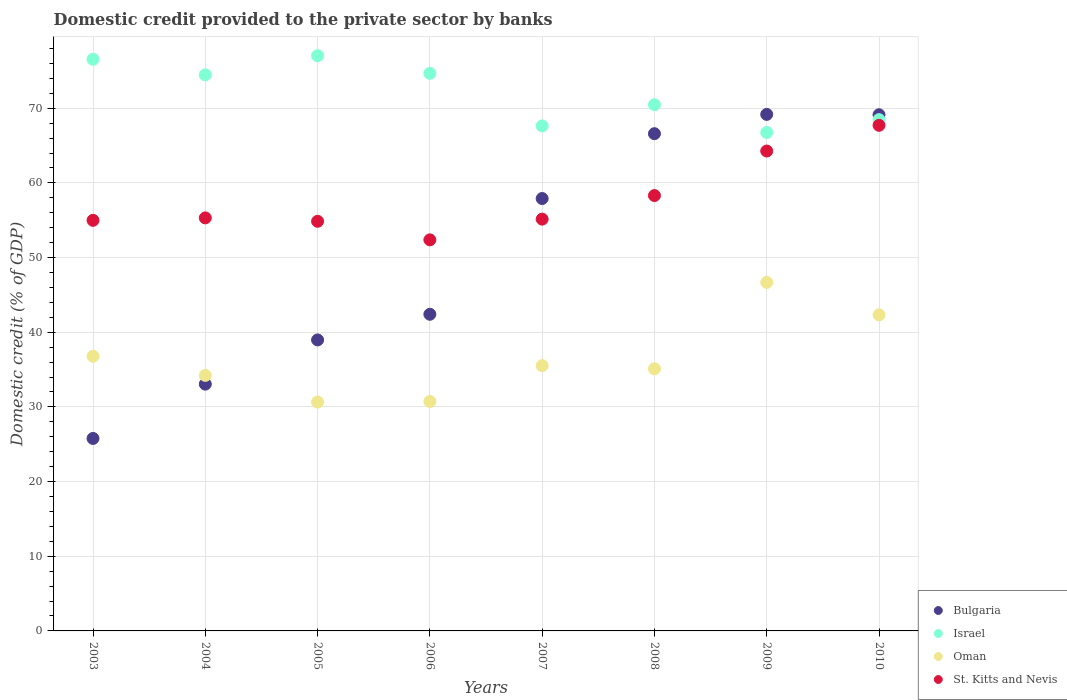How many different coloured dotlines are there?
Make the answer very short. 4. What is the domestic credit provided to the private sector by banks in Israel in 2010?
Keep it short and to the point. 68.48. Across all years, what is the maximum domestic credit provided to the private sector by banks in Bulgaria?
Provide a succinct answer. 69.18. Across all years, what is the minimum domestic credit provided to the private sector by banks in Oman?
Ensure brevity in your answer.  30.65. What is the total domestic credit provided to the private sector by banks in Bulgaria in the graph?
Your answer should be compact. 403.03. What is the difference between the domestic credit provided to the private sector by banks in Bulgaria in 2003 and that in 2007?
Give a very brief answer. -32.13. What is the difference between the domestic credit provided to the private sector by banks in Israel in 2005 and the domestic credit provided to the private sector by banks in Oman in 2007?
Your answer should be very brief. 41.51. What is the average domestic credit provided to the private sector by banks in St. Kitts and Nevis per year?
Your answer should be compact. 57.87. In the year 2010, what is the difference between the domestic credit provided to the private sector by banks in Oman and domestic credit provided to the private sector by banks in Bulgaria?
Ensure brevity in your answer.  -26.8. What is the ratio of the domestic credit provided to the private sector by banks in Israel in 2003 to that in 2005?
Ensure brevity in your answer.  0.99. Is the domestic credit provided to the private sector by banks in Bulgaria in 2003 less than that in 2005?
Provide a succinct answer. Yes. Is the difference between the domestic credit provided to the private sector by banks in Oman in 2004 and 2009 greater than the difference between the domestic credit provided to the private sector by banks in Bulgaria in 2004 and 2009?
Offer a very short reply. Yes. What is the difference between the highest and the second highest domestic credit provided to the private sector by banks in St. Kitts and Nevis?
Provide a short and direct response. 3.45. What is the difference between the highest and the lowest domestic credit provided to the private sector by banks in Oman?
Provide a succinct answer. 16.03. Is the sum of the domestic credit provided to the private sector by banks in Oman in 2008 and 2009 greater than the maximum domestic credit provided to the private sector by banks in St. Kitts and Nevis across all years?
Give a very brief answer. Yes. Does the domestic credit provided to the private sector by banks in Bulgaria monotonically increase over the years?
Give a very brief answer. No. Is the domestic credit provided to the private sector by banks in Israel strictly less than the domestic credit provided to the private sector by banks in St. Kitts and Nevis over the years?
Ensure brevity in your answer.  No. How many years are there in the graph?
Your answer should be very brief. 8. What is the difference between two consecutive major ticks on the Y-axis?
Provide a succinct answer. 10. Are the values on the major ticks of Y-axis written in scientific E-notation?
Give a very brief answer. No. Does the graph contain any zero values?
Offer a very short reply. No. How are the legend labels stacked?
Your answer should be compact. Vertical. What is the title of the graph?
Ensure brevity in your answer.  Domestic credit provided to the private sector by banks. What is the label or title of the X-axis?
Ensure brevity in your answer.  Years. What is the label or title of the Y-axis?
Offer a terse response. Domestic credit (% of GDP). What is the Domestic credit (% of GDP) in Bulgaria in 2003?
Keep it short and to the point. 25.78. What is the Domestic credit (% of GDP) in Israel in 2003?
Ensure brevity in your answer.  76.56. What is the Domestic credit (% of GDP) of Oman in 2003?
Your answer should be compact. 36.79. What is the Domestic credit (% of GDP) of St. Kitts and Nevis in 2003?
Your response must be concise. 54.99. What is the Domestic credit (% of GDP) in Bulgaria in 2004?
Your response must be concise. 33.05. What is the Domestic credit (% of GDP) in Israel in 2004?
Offer a very short reply. 74.47. What is the Domestic credit (% of GDP) in Oman in 2004?
Provide a succinct answer. 34.23. What is the Domestic credit (% of GDP) of St. Kitts and Nevis in 2004?
Provide a succinct answer. 55.32. What is the Domestic credit (% of GDP) in Bulgaria in 2005?
Your answer should be very brief. 38.97. What is the Domestic credit (% of GDP) in Israel in 2005?
Offer a very short reply. 77.04. What is the Domestic credit (% of GDP) in Oman in 2005?
Your answer should be very brief. 30.65. What is the Domestic credit (% of GDP) of St. Kitts and Nevis in 2005?
Keep it short and to the point. 54.86. What is the Domestic credit (% of GDP) of Bulgaria in 2006?
Ensure brevity in your answer.  42.41. What is the Domestic credit (% of GDP) of Israel in 2006?
Offer a very short reply. 74.67. What is the Domestic credit (% of GDP) in Oman in 2006?
Ensure brevity in your answer.  30.73. What is the Domestic credit (% of GDP) in St. Kitts and Nevis in 2006?
Provide a succinct answer. 52.38. What is the Domestic credit (% of GDP) in Bulgaria in 2007?
Your response must be concise. 57.91. What is the Domestic credit (% of GDP) in Israel in 2007?
Your answer should be compact. 67.64. What is the Domestic credit (% of GDP) of Oman in 2007?
Your response must be concise. 35.53. What is the Domestic credit (% of GDP) in St. Kitts and Nevis in 2007?
Offer a terse response. 55.15. What is the Domestic credit (% of GDP) of Bulgaria in 2008?
Your response must be concise. 66.59. What is the Domestic credit (% of GDP) of Israel in 2008?
Ensure brevity in your answer.  70.47. What is the Domestic credit (% of GDP) in Oman in 2008?
Your answer should be compact. 35.11. What is the Domestic credit (% of GDP) in St. Kitts and Nevis in 2008?
Make the answer very short. 58.31. What is the Domestic credit (% of GDP) in Bulgaria in 2009?
Offer a very short reply. 69.18. What is the Domestic credit (% of GDP) of Israel in 2009?
Provide a succinct answer. 66.76. What is the Domestic credit (% of GDP) of Oman in 2009?
Provide a short and direct response. 46.68. What is the Domestic credit (% of GDP) in St. Kitts and Nevis in 2009?
Your response must be concise. 64.27. What is the Domestic credit (% of GDP) of Bulgaria in 2010?
Keep it short and to the point. 69.13. What is the Domestic credit (% of GDP) of Israel in 2010?
Give a very brief answer. 68.48. What is the Domestic credit (% of GDP) of Oman in 2010?
Keep it short and to the point. 42.33. What is the Domestic credit (% of GDP) of St. Kitts and Nevis in 2010?
Your response must be concise. 67.72. Across all years, what is the maximum Domestic credit (% of GDP) in Bulgaria?
Offer a very short reply. 69.18. Across all years, what is the maximum Domestic credit (% of GDP) of Israel?
Your response must be concise. 77.04. Across all years, what is the maximum Domestic credit (% of GDP) in Oman?
Give a very brief answer. 46.68. Across all years, what is the maximum Domestic credit (% of GDP) in St. Kitts and Nevis?
Ensure brevity in your answer.  67.72. Across all years, what is the minimum Domestic credit (% of GDP) of Bulgaria?
Provide a succinct answer. 25.78. Across all years, what is the minimum Domestic credit (% of GDP) of Israel?
Your response must be concise. 66.76. Across all years, what is the minimum Domestic credit (% of GDP) of Oman?
Give a very brief answer. 30.65. Across all years, what is the minimum Domestic credit (% of GDP) in St. Kitts and Nevis?
Ensure brevity in your answer.  52.38. What is the total Domestic credit (% of GDP) of Bulgaria in the graph?
Offer a very short reply. 403.03. What is the total Domestic credit (% of GDP) of Israel in the graph?
Provide a short and direct response. 576.09. What is the total Domestic credit (% of GDP) of Oman in the graph?
Your response must be concise. 292.04. What is the total Domestic credit (% of GDP) in St. Kitts and Nevis in the graph?
Provide a succinct answer. 463. What is the difference between the Domestic credit (% of GDP) in Bulgaria in 2003 and that in 2004?
Provide a short and direct response. -7.27. What is the difference between the Domestic credit (% of GDP) of Israel in 2003 and that in 2004?
Ensure brevity in your answer.  2.08. What is the difference between the Domestic credit (% of GDP) in Oman in 2003 and that in 2004?
Ensure brevity in your answer.  2.56. What is the difference between the Domestic credit (% of GDP) in St. Kitts and Nevis in 2003 and that in 2004?
Your answer should be very brief. -0.33. What is the difference between the Domestic credit (% of GDP) of Bulgaria in 2003 and that in 2005?
Make the answer very short. -13.19. What is the difference between the Domestic credit (% of GDP) in Israel in 2003 and that in 2005?
Provide a succinct answer. -0.48. What is the difference between the Domestic credit (% of GDP) in Oman in 2003 and that in 2005?
Make the answer very short. 6.14. What is the difference between the Domestic credit (% of GDP) in St. Kitts and Nevis in 2003 and that in 2005?
Provide a succinct answer. 0.13. What is the difference between the Domestic credit (% of GDP) of Bulgaria in 2003 and that in 2006?
Give a very brief answer. -16.63. What is the difference between the Domestic credit (% of GDP) of Israel in 2003 and that in 2006?
Ensure brevity in your answer.  1.88. What is the difference between the Domestic credit (% of GDP) of Oman in 2003 and that in 2006?
Provide a succinct answer. 6.06. What is the difference between the Domestic credit (% of GDP) in St. Kitts and Nevis in 2003 and that in 2006?
Offer a very short reply. 2.62. What is the difference between the Domestic credit (% of GDP) in Bulgaria in 2003 and that in 2007?
Your answer should be very brief. -32.13. What is the difference between the Domestic credit (% of GDP) of Israel in 2003 and that in 2007?
Ensure brevity in your answer.  8.92. What is the difference between the Domestic credit (% of GDP) of Oman in 2003 and that in 2007?
Keep it short and to the point. 1.26. What is the difference between the Domestic credit (% of GDP) in St. Kitts and Nevis in 2003 and that in 2007?
Offer a very short reply. -0.16. What is the difference between the Domestic credit (% of GDP) of Bulgaria in 2003 and that in 2008?
Provide a short and direct response. -40.82. What is the difference between the Domestic credit (% of GDP) of Israel in 2003 and that in 2008?
Provide a succinct answer. 6.09. What is the difference between the Domestic credit (% of GDP) of Oman in 2003 and that in 2008?
Provide a succinct answer. 1.68. What is the difference between the Domestic credit (% of GDP) of St. Kitts and Nevis in 2003 and that in 2008?
Offer a terse response. -3.32. What is the difference between the Domestic credit (% of GDP) of Bulgaria in 2003 and that in 2009?
Your response must be concise. -43.4. What is the difference between the Domestic credit (% of GDP) in Israel in 2003 and that in 2009?
Make the answer very short. 9.8. What is the difference between the Domestic credit (% of GDP) of Oman in 2003 and that in 2009?
Give a very brief answer. -9.89. What is the difference between the Domestic credit (% of GDP) of St. Kitts and Nevis in 2003 and that in 2009?
Ensure brevity in your answer.  -9.28. What is the difference between the Domestic credit (% of GDP) of Bulgaria in 2003 and that in 2010?
Ensure brevity in your answer.  -43.35. What is the difference between the Domestic credit (% of GDP) in Israel in 2003 and that in 2010?
Provide a short and direct response. 8.08. What is the difference between the Domestic credit (% of GDP) in Oman in 2003 and that in 2010?
Offer a terse response. -5.55. What is the difference between the Domestic credit (% of GDP) of St. Kitts and Nevis in 2003 and that in 2010?
Your answer should be compact. -12.73. What is the difference between the Domestic credit (% of GDP) in Bulgaria in 2004 and that in 2005?
Give a very brief answer. -5.92. What is the difference between the Domestic credit (% of GDP) of Israel in 2004 and that in 2005?
Make the answer very short. -2.56. What is the difference between the Domestic credit (% of GDP) in Oman in 2004 and that in 2005?
Provide a succinct answer. 3.58. What is the difference between the Domestic credit (% of GDP) of St. Kitts and Nevis in 2004 and that in 2005?
Ensure brevity in your answer.  0.45. What is the difference between the Domestic credit (% of GDP) of Bulgaria in 2004 and that in 2006?
Give a very brief answer. -9.36. What is the difference between the Domestic credit (% of GDP) in Oman in 2004 and that in 2006?
Your response must be concise. 3.5. What is the difference between the Domestic credit (% of GDP) of St. Kitts and Nevis in 2004 and that in 2006?
Offer a very short reply. 2.94. What is the difference between the Domestic credit (% of GDP) of Bulgaria in 2004 and that in 2007?
Keep it short and to the point. -24.86. What is the difference between the Domestic credit (% of GDP) of Israel in 2004 and that in 2007?
Keep it short and to the point. 6.84. What is the difference between the Domestic credit (% of GDP) in Oman in 2004 and that in 2007?
Provide a short and direct response. -1.3. What is the difference between the Domestic credit (% of GDP) in St. Kitts and Nevis in 2004 and that in 2007?
Provide a succinct answer. 0.17. What is the difference between the Domestic credit (% of GDP) of Bulgaria in 2004 and that in 2008?
Keep it short and to the point. -33.54. What is the difference between the Domestic credit (% of GDP) in Israel in 2004 and that in 2008?
Offer a very short reply. 4.01. What is the difference between the Domestic credit (% of GDP) of Oman in 2004 and that in 2008?
Offer a terse response. -0.88. What is the difference between the Domestic credit (% of GDP) of St. Kitts and Nevis in 2004 and that in 2008?
Give a very brief answer. -2.99. What is the difference between the Domestic credit (% of GDP) in Bulgaria in 2004 and that in 2009?
Ensure brevity in your answer.  -36.13. What is the difference between the Domestic credit (% of GDP) in Israel in 2004 and that in 2009?
Give a very brief answer. 7.72. What is the difference between the Domestic credit (% of GDP) in Oman in 2004 and that in 2009?
Your answer should be very brief. -12.45. What is the difference between the Domestic credit (% of GDP) of St. Kitts and Nevis in 2004 and that in 2009?
Your answer should be very brief. -8.95. What is the difference between the Domestic credit (% of GDP) of Bulgaria in 2004 and that in 2010?
Your answer should be very brief. -36.08. What is the difference between the Domestic credit (% of GDP) of Israel in 2004 and that in 2010?
Ensure brevity in your answer.  6. What is the difference between the Domestic credit (% of GDP) of Oman in 2004 and that in 2010?
Provide a short and direct response. -8.11. What is the difference between the Domestic credit (% of GDP) in St. Kitts and Nevis in 2004 and that in 2010?
Make the answer very short. -12.4. What is the difference between the Domestic credit (% of GDP) in Bulgaria in 2005 and that in 2006?
Give a very brief answer. -3.44. What is the difference between the Domestic credit (% of GDP) in Israel in 2005 and that in 2006?
Offer a terse response. 2.36. What is the difference between the Domestic credit (% of GDP) in Oman in 2005 and that in 2006?
Make the answer very short. -0.08. What is the difference between the Domestic credit (% of GDP) in St. Kitts and Nevis in 2005 and that in 2006?
Provide a succinct answer. 2.49. What is the difference between the Domestic credit (% of GDP) of Bulgaria in 2005 and that in 2007?
Keep it short and to the point. -18.94. What is the difference between the Domestic credit (% of GDP) in Israel in 2005 and that in 2007?
Make the answer very short. 9.4. What is the difference between the Domestic credit (% of GDP) of Oman in 2005 and that in 2007?
Provide a short and direct response. -4.88. What is the difference between the Domestic credit (% of GDP) of St. Kitts and Nevis in 2005 and that in 2007?
Provide a succinct answer. -0.29. What is the difference between the Domestic credit (% of GDP) in Bulgaria in 2005 and that in 2008?
Offer a terse response. -27.62. What is the difference between the Domestic credit (% of GDP) in Israel in 2005 and that in 2008?
Give a very brief answer. 6.57. What is the difference between the Domestic credit (% of GDP) in Oman in 2005 and that in 2008?
Your answer should be compact. -4.46. What is the difference between the Domestic credit (% of GDP) in St. Kitts and Nevis in 2005 and that in 2008?
Keep it short and to the point. -3.44. What is the difference between the Domestic credit (% of GDP) of Bulgaria in 2005 and that in 2009?
Provide a succinct answer. -30.21. What is the difference between the Domestic credit (% of GDP) of Israel in 2005 and that in 2009?
Keep it short and to the point. 10.28. What is the difference between the Domestic credit (% of GDP) in Oman in 2005 and that in 2009?
Give a very brief answer. -16.03. What is the difference between the Domestic credit (% of GDP) of St. Kitts and Nevis in 2005 and that in 2009?
Make the answer very short. -9.41. What is the difference between the Domestic credit (% of GDP) in Bulgaria in 2005 and that in 2010?
Your response must be concise. -30.16. What is the difference between the Domestic credit (% of GDP) in Israel in 2005 and that in 2010?
Your answer should be compact. 8.56. What is the difference between the Domestic credit (% of GDP) in Oman in 2005 and that in 2010?
Provide a succinct answer. -11.68. What is the difference between the Domestic credit (% of GDP) of St. Kitts and Nevis in 2005 and that in 2010?
Offer a terse response. -12.85. What is the difference between the Domestic credit (% of GDP) of Bulgaria in 2006 and that in 2007?
Ensure brevity in your answer.  -15.5. What is the difference between the Domestic credit (% of GDP) in Israel in 2006 and that in 2007?
Make the answer very short. 7.04. What is the difference between the Domestic credit (% of GDP) of Oman in 2006 and that in 2007?
Your answer should be compact. -4.8. What is the difference between the Domestic credit (% of GDP) in St. Kitts and Nevis in 2006 and that in 2007?
Give a very brief answer. -2.77. What is the difference between the Domestic credit (% of GDP) of Bulgaria in 2006 and that in 2008?
Ensure brevity in your answer.  -24.19. What is the difference between the Domestic credit (% of GDP) in Israel in 2006 and that in 2008?
Give a very brief answer. 4.21. What is the difference between the Domestic credit (% of GDP) in Oman in 2006 and that in 2008?
Give a very brief answer. -4.38. What is the difference between the Domestic credit (% of GDP) in St. Kitts and Nevis in 2006 and that in 2008?
Your response must be concise. -5.93. What is the difference between the Domestic credit (% of GDP) in Bulgaria in 2006 and that in 2009?
Give a very brief answer. -26.77. What is the difference between the Domestic credit (% of GDP) of Israel in 2006 and that in 2009?
Provide a short and direct response. 7.92. What is the difference between the Domestic credit (% of GDP) of Oman in 2006 and that in 2009?
Make the answer very short. -15.95. What is the difference between the Domestic credit (% of GDP) of St. Kitts and Nevis in 2006 and that in 2009?
Your response must be concise. -11.9. What is the difference between the Domestic credit (% of GDP) of Bulgaria in 2006 and that in 2010?
Your response must be concise. -26.72. What is the difference between the Domestic credit (% of GDP) in Israel in 2006 and that in 2010?
Keep it short and to the point. 6.2. What is the difference between the Domestic credit (% of GDP) of Oman in 2006 and that in 2010?
Offer a very short reply. -11.6. What is the difference between the Domestic credit (% of GDP) in St. Kitts and Nevis in 2006 and that in 2010?
Provide a succinct answer. -15.34. What is the difference between the Domestic credit (% of GDP) in Bulgaria in 2007 and that in 2008?
Offer a terse response. -8.68. What is the difference between the Domestic credit (% of GDP) of Israel in 2007 and that in 2008?
Offer a terse response. -2.83. What is the difference between the Domestic credit (% of GDP) of Oman in 2007 and that in 2008?
Make the answer very short. 0.42. What is the difference between the Domestic credit (% of GDP) of St. Kitts and Nevis in 2007 and that in 2008?
Make the answer very short. -3.16. What is the difference between the Domestic credit (% of GDP) of Bulgaria in 2007 and that in 2009?
Offer a very short reply. -11.27. What is the difference between the Domestic credit (% of GDP) of Israel in 2007 and that in 2009?
Ensure brevity in your answer.  0.88. What is the difference between the Domestic credit (% of GDP) of Oman in 2007 and that in 2009?
Offer a very short reply. -11.15. What is the difference between the Domestic credit (% of GDP) of St. Kitts and Nevis in 2007 and that in 2009?
Give a very brief answer. -9.12. What is the difference between the Domestic credit (% of GDP) of Bulgaria in 2007 and that in 2010?
Your answer should be very brief. -11.22. What is the difference between the Domestic credit (% of GDP) in Israel in 2007 and that in 2010?
Offer a terse response. -0.84. What is the difference between the Domestic credit (% of GDP) in Oman in 2007 and that in 2010?
Keep it short and to the point. -6.81. What is the difference between the Domestic credit (% of GDP) in St. Kitts and Nevis in 2007 and that in 2010?
Make the answer very short. -12.57. What is the difference between the Domestic credit (% of GDP) in Bulgaria in 2008 and that in 2009?
Make the answer very short. -2.58. What is the difference between the Domestic credit (% of GDP) in Israel in 2008 and that in 2009?
Your answer should be very brief. 3.71. What is the difference between the Domestic credit (% of GDP) of Oman in 2008 and that in 2009?
Give a very brief answer. -11.57. What is the difference between the Domestic credit (% of GDP) of St. Kitts and Nevis in 2008 and that in 2009?
Your response must be concise. -5.96. What is the difference between the Domestic credit (% of GDP) in Bulgaria in 2008 and that in 2010?
Give a very brief answer. -2.54. What is the difference between the Domestic credit (% of GDP) of Israel in 2008 and that in 2010?
Your answer should be very brief. 1.99. What is the difference between the Domestic credit (% of GDP) in Oman in 2008 and that in 2010?
Make the answer very short. -7.23. What is the difference between the Domestic credit (% of GDP) in St. Kitts and Nevis in 2008 and that in 2010?
Your response must be concise. -9.41. What is the difference between the Domestic credit (% of GDP) of Bulgaria in 2009 and that in 2010?
Make the answer very short. 0.05. What is the difference between the Domestic credit (% of GDP) of Israel in 2009 and that in 2010?
Your response must be concise. -1.72. What is the difference between the Domestic credit (% of GDP) of Oman in 2009 and that in 2010?
Provide a short and direct response. 4.34. What is the difference between the Domestic credit (% of GDP) in St. Kitts and Nevis in 2009 and that in 2010?
Give a very brief answer. -3.45. What is the difference between the Domestic credit (% of GDP) in Bulgaria in 2003 and the Domestic credit (% of GDP) in Israel in 2004?
Keep it short and to the point. -48.7. What is the difference between the Domestic credit (% of GDP) of Bulgaria in 2003 and the Domestic credit (% of GDP) of Oman in 2004?
Make the answer very short. -8.45. What is the difference between the Domestic credit (% of GDP) in Bulgaria in 2003 and the Domestic credit (% of GDP) in St. Kitts and Nevis in 2004?
Provide a succinct answer. -29.54. What is the difference between the Domestic credit (% of GDP) in Israel in 2003 and the Domestic credit (% of GDP) in Oman in 2004?
Ensure brevity in your answer.  42.33. What is the difference between the Domestic credit (% of GDP) of Israel in 2003 and the Domestic credit (% of GDP) of St. Kitts and Nevis in 2004?
Your answer should be very brief. 21.24. What is the difference between the Domestic credit (% of GDP) in Oman in 2003 and the Domestic credit (% of GDP) in St. Kitts and Nevis in 2004?
Your answer should be compact. -18.53. What is the difference between the Domestic credit (% of GDP) in Bulgaria in 2003 and the Domestic credit (% of GDP) in Israel in 2005?
Keep it short and to the point. -51.26. What is the difference between the Domestic credit (% of GDP) of Bulgaria in 2003 and the Domestic credit (% of GDP) of Oman in 2005?
Make the answer very short. -4.87. What is the difference between the Domestic credit (% of GDP) in Bulgaria in 2003 and the Domestic credit (% of GDP) in St. Kitts and Nevis in 2005?
Your answer should be very brief. -29.09. What is the difference between the Domestic credit (% of GDP) in Israel in 2003 and the Domestic credit (% of GDP) in Oman in 2005?
Your answer should be very brief. 45.91. What is the difference between the Domestic credit (% of GDP) in Israel in 2003 and the Domestic credit (% of GDP) in St. Kitts and Nevis in 2005?
Make the answer very short. 21.7. What is the difference between the Domestic credit (% of GDP) of Oman in 2003 and the Domestic credit (% of GDP) of St. Kitts and Nevis in 2005?
Make the answer very short. -18.08. What is the difference between the Domestic credit (% of GDP) in Bulgaria in 2003 and the Domestic credit (% of GDP) in Israel in 2006?
Offer a terse response. -48.9. What is the difference between the Domestic credit (% of GDP) in Bulgaria in 2003 and the Domestic credit (% of GDP) in Oman in 2006?
Your answer should be compact. -4.95. What is the difference between the Domestic credit (% of GDP) in Bulgaria in 2003 and the Domestic credit (% of GDP) in St. Kitts and Nevis in 2006?
Offer a terse response. -26.6. What is the difference between the Domestic credit (% of GDP) of Israel in 2003 and the Domestic credit (% of GDP) of Oman in 2006?
Ensure brevity in your answer.  45.83. What is the difference between the Domestic credit (% of GDP) in Israel in 2003 and the Domestic credit (% of GDP) in St. Kitts and Nevis in 2006?
Offer a terse response. 24.18. What is the difference between the Domestic credit (% of GDP) in Oman in 2003 and the Domestic credit (% of GDP) in St. Kitts and Nevis in 2006?
Offer a very short reply. -15.59. What is the difference between the Domestic credit (% of GDP) of Bulgaria in 2003 and the Domestic credit (% of GDP) of Israel in 2007?
Your response must be concise. -41.86. What is the difference between the Domestic credit (% of GDP) in Bulgaria in 2003 and the Domestic credit (% of GDP) in Oman in 2007?
Provide a succinct answer. -9.75. What is the difference between the Domestic credit (% of GDP) of Bulgaria in 2003 and the Domestic credit (% of GDP) of St. Kitts and Nevis in 2007?
Your answer should be very brief. -29.37. What is the difference between the Domestic credit (% of GDP) in Israel in 2003 and the Domestic credit (% of GDP) in Oman in 2007?
Ensure brevity in your answer.  41.03. What is the difference between the Domestic credit (% of GDP) of Israel in 2003 and the Domestic credit (% of GDP) of St. Kitts and Nevis in 2007?
Give a very brief answer. 21.41. What is the difference between the Domestic credit (% of GDP) of Oman in 2003 and the Domestic credit (% of GDP) of St. Kitts and Nevis in 2007?
Provide a succinct answer. -18.36. What is the difference between the Domestic credit (% of GDP) of Bulgaria in 2003 and the Domestic credit (% of GDP) of Israel in 2008?
Keep it short and to the point. -44.69. What is the difference between the Domestic credit (% of GDP) in Bulgaria in 2003 and the Domestic credit (% of GDP) in Oman in 2008?
Provide a short and direct response. -9.33. What is the difference between the Domestic credit (% of GDP) of Bulgaria in 2003 and the Domestic credit (% of GDP) of St. Kitts and Nevis in 2008?
Give a very brief answer. -32.53. What is the difference between the Domestic credit (% of GDP) in Israel in 2003 and the Domestic credit (% of GDP) in Oman in 2008?
Offer a very short reply. 41.45. What is the difference between the Domestic credit (% of GDP) in Israel in 2003 and the Domestic credit (% of GDP) in St. Kitts and Nevis in 2008?
Provide a short and direct response. 18.25. What is the difference between the Domestic credit (% of GDP) in Oman in 2003 and the Domestic credit (% of GDP) in St. Kitts and Nevis in 2008?
Provide a short and direct response. -21.52. What is the difference between the Domestic credit (% of GDP) in Bulgaria in 2003 and the Domestic credit (% of GDP) in Israel in 2009?
Give a very brief answer. -40.98. What is the difference between the Domestic credit (% of GDP) of Bulgaria in 2003 and the Domestic credit (% of GDP) of Oman in 2009?
Ensure brevity in your answer.  -20.9. What is the difference between the Domestic credit (% of GDP) of Bulgaria in 2003 and the Domestic credit (% of GDP) of St. Kitts and Nevis in 2009?
Offer a terse response. -38.49. What is the difference between the Domestic credit (% of GDP) of Israel in 2003 and the Domestic credit (% of GDP) of Oman in 2009?
Provide a short and direct response. 29.88. What is the difference between the Domestic credit (% of GDP) in Israel in 2003 and the Domestic credit (% of GDP) in St. Kitts and Nevis in 2009?
Provide a succinct answer. 12.29. What is the difference between the Domestic credit (% of GDP) in Oman in 2003 and the Domestic credit (% of GDP) in St. Kitts and Nevis in 2009?
Your answer should be very brief. -27.48. What is the difference between the Domestic credit (% of GDP) in Bulgaria in 2003 and the Domestic credit (% of GDP) in Israel in 2010?
Ensure brevity in your answer.  -42.7. What is the difference between the Domestic credit (% of GDP) in Bulgaria in 2003 and the Domestic credit (% of GDP) in Oman in 2010?
Your answer should be compact. -16.56. What is the difference between the Domestic credit (% of GDP) of Bulgaria in 2003 and the Domestic credit (% of GDP) of St. Kitts and Nevis in 2010?
Ensure brevity in your answer.  -41.94. What is the difference between the Domestic credit (% of GDP) in Israel in 2003 and the Domestic credit (% of GDP) in Oman in 2010?
Keep it short and to the point. 34.23. What is the difference between the Domestic credit (% of GDP) in Israel in 2003 and the Domestic credit (% of GDP) in St. Kitts and Nevis in 2010?
Give a very brief answer. 8.84. What is the difference between the Domestic credit (% of GDP) in Oman in 2003 and the Domestic credit (% of GDP) in St. Kitts and Nevis in 2010?
Make the answer very short. -30.93. What is the difference between the Domestic credit (% of GDP) in Bulgaria in 2004 and the Domestic credit (% of GDP) in Israel in 2005?
Offer a terse response. -43.99. What is the difference between the Domestic credit (% of GDP) of Bulgaria in 2004 and the Domestic credit (% of GDP) of Oman in 2005?
Your answer should be compact. 2.4. What is the difference between the Domestic credit (% of GDP) of Bulgaria in 2004 and the Domestic credit (% of GDP) of St. Kitts and Nevis in 2005?
Your answer should be very brief. -21.81. What is the difference between the Domestic credit (% of GDP) in Israel in 2004 and the Domestic credit (% of GDP) in Oman in 2005?
Ensure brevity in your answer.  43.82. What is the difference between the Domestic credit (% of GDP) of Israel in 2004 and the Domestic credit (% of GDP) of St. Kitts and Nevis in 2005?
Provide a short and direct response. 19.61. What is the difference between the Domestic credit (% of GDP) in Oman in 2004 and the Domestic credit (% of GDP) in St. Kitts and Nevis in 2005?
Offer a very short reply. -20.64. What is the difference between the Domestic credit (% of GDP) in Bulgaria in 2004 and the Domestic credit (% of GDP) in Israel in 2006?
Your answer should be compact. -41.62. What is the difference between the Domestic credit (% of GDP) of Bulgaria in 2004 and the Domestic credit (% of GDP) of Oman in 2006?
Your response must be concise. 2.32. What is the difference between the Domestic credit (% of GDP) in Bulgaria in 2004 and the Domestic credit (% of GDP) in St. Kitts and Nevis in 2006?
Provide a short and direct response. -19.33. What is the difference between the Domestic credit (% of GDP) of Israel in 2004 and the Domestic credit (% of GDP) of Oman in 2006?
Provide a succinct answer. 43.74. What is the difference between the Domestic credit (% of GDP) of Israel in 2004 and the Domestic credit (% of GDP) of St. Kitts and Nevis in 2006?
Ensure brevity in your answer.  22.1. What is the difference between the Domestic credit (% of GDP) of Oman in 2004 and the Domestic credit (% of GDP) of St. Kitts and Nevis in 2006?
Make the answer very short. -18.15. What is the difference between the Domestic credit (% of GDP) in Bulgaria in 2004 and the Domestic credit (% of GDP) in Israel in 2007?
Your answer should be very brief. -34.59. What is the difference between the Domestic credit (% of GDP) of Bulgaria in 2004 and the Domestic credit (% of GDP) of Oman in 2007?
Offer a terse response. -2.48. What is the difference between the Domestic credit (% of GDP) in Bulgaria in 2004 and the Domestic credit (% of GDP) in St. Kitts and Nevis in 2007?
Provide a succinct answer. -22.1. What is the difference between the Domestic credit (% of GDP) of Israel in 2004 and the Domestic credit (% of GDP) of Oman in 2007?
Ensure brevity in your answer.  38.95. What is the difference between the Domestic credit (% of GDP) of Israel in 2004 and the Domestic credit (% of GDP) of St. Kitts and Nevis in 2007?
Your answer should be compact. 19.32. What is the difference between the Domestic credit (% of GDP) in Oman in 2004 and the Domestic credit (% of GDP) in St. Kitts and Nevis in 2007?
Ensure brevity in your answer.  -20.93. What is the difference between the Domestic credit (% of GDP) in Bulgaria in 2004 and the Domestic credit (% of GDP) in Israel in 2008?
Keep it short and to the point. -37.42. What is the difference between the Domestic credit (% of GDP) of Bulgaria in 2004 and the Domestic credit (% of GDP) of Oman in 2008?
Offer a very short reply. -2.06. What is the difference between the Domestic credit (% of GDP) of Bulgaria in 2004 and the Domestic credit (% of GDP) of St. Kitts and Nevis in 2008?
Keep it short and to the point. -25.26. What is the difference between the Domestic credit (% of GDP) of Israel in 2004 and the Domestic credit (% of GDP) of Oman in 2008?
Your answer should be compact. 39.37. What is the difference between the Domestic credit (% of GDP) of Israel in 2004 and the Domestic credit (% of GDP) of St. Kitts and Nevis in 2008?
Provide a short and direct response. 16.17. What is the difference between the Domestic credit (% of GDP) in Oman in 2004 and the Domestic credit (% of GDP) in St. Kitts and Nevis in 2008?
Provide a short and direct response. -24.08. What is the difference between the Domestic credit (% of GDP) of Bulgaria in 2004 and the Domestic credit (% of GDP) of Israel in 2009?
Ensure brevity in your answer.  -33.71. What is the difference between the Domestic credit (% of GDP) in Bulgaria in 2004 and the Domestic credit (% of GDP) in Oman in 2009?
Give a very brief answer. -13.63. What is the difference between the Domestic credit (% of GDP) in Bulgaria in 2004 and the Domestic credit (% of GDP) in St. Kitts and Nevis in 2009?
Give a very brief answer. -31.22. What is the difference between the Domestic credit (% of GDP) in Israel in 2004 and the Domestic credit (% of GDP) in Oman in 2009?
Give a very brief answer. 27.8. What is the difference between the Domestic credit (% of GDP) in Israel in 2004 and the Domestic credit (% of GDP) in St. Kitts and Nevis in 2009?
Your response must be concise. 10.2. What is the difference between the Domestic credit (% of GDP) in Oman in 2004 and the Domestic credit (% of GDP) in St. Kitts and Nevis in 2009?
Your answer should be compact. -30.05. What is the difference between the Domestic credit (% of GDP) of Bulgaria in 2004 and the Domestic credit (% of GDP) of Israel in 2010?
Provide a succinct answer. -35.43. What is the difference between the Domestic credit (% of GDP) in Bulgaria in 2004 and the Domestic credit (% of GDP) in Oman in 2010?
Offer a very short reply. -9.28. What is the difference between the Domestic credit (% of GDP) of Bulgaria in 2004 and the Domestic credit (% of GDP) of St. Kitts and Nevis in 2010?
Your answer should be compact. -34.67. What is the difference between the Domestic credit (% of GDP) in Israel in 2004 and the Domestic credit (% of GDP) in Oman in 2010?
Make the answer very short. 32.14. What is the difference between the Domestic credit (% of GDP) in Israel in 2004 and the Domestic credit (% of GDP) in St. Kitts and Nevis in 2010?
Your answer should be very brief. 6.76. What is the difference between the Domestic credit (% of GDP) in Oman in 2004 and the Domestic credit (% of GDP) in St. Kitts and Nevis in 2010?
Your response must be concise. -33.49. What is the difference between the Domestic credit (% of GDP) of Bulgaria in 2005 and the Domestic credit (% of GDP) of Israel in 2006?
Offer a very short reply. -35.7. What is the difference between the Domestic credit (% of GDP) in Bulgaria in 2005 and the Domestic credit (% of GDP) in Oman in 2006?
Provide a succinct answer. 8.24. What is the difference between the Domestic credit (% of GDP) in Bulgaria in 2005 and the Domestic credit (% of GDP) in St. Kitts and Nevis in 2006?
Your response must be concise. -13.4. What is the difference between the Domestic credit (% of GDP) of Israel in 2005 and the Domestic credit (% of GDP) of Oman in 2006?
Provide a succinct answer. 46.31. What is the difference between the Domestic credit (% of GDP) of Israel in 2005 and the Domestic credit (% of GDP) of St. Kitts and Nevis in 2006?
Give a very brief answer. 24.66. What is the difference between the Domestic credit (% of GDP) of Oman in 2005 and the Domestic credit (% of GDP) of St. Kitts and Nevis in 2006?
Your answer should be compact. -21.73. What is the difference between the Domestic credit (% of GDP) in Bulgaria in 2005 and the Domestic credit (% of GDP) in Israel in 2007?
Your answer should be very brief. -28.67. What is the difference between the Domestic credit (% of GDP) of Bulgaria in 2005 and the Domestic credit (% of GDP) of Oman in 2007?
Make the answer very short. 3.45. What is the difference between the Domestic credit (% of GDP) of Bulgaria in 2005 and the Domestic credit (% of GDP) of St. Kitts and Nevis in 2007?
Give a very brief answer. -16.18. What is the difference between the Domestic credit (% of GDP) of Israel in 2005 and the Domestic credit (% of GDP) of Oman in 2007?
Ensure brevity in your answer.  41.51. What is the difference between the Domestic credit (% of GDP) of Israel in 2005 and the Domestic credit (% of GDP) of St. Kitts and Nevis in 2007?
Keep it short and to the point. 21.89. What is the difference between the Domestic credit (% of GDP) of Oman in 2005 and the Domestic credit (% of GDP) of St. Kitts and Nevis in 2007?
Your answer should be compact. -24.5. What is the difference between the Domestic credit (% of GDP) of Bulgaria in 2005 and the Domestic credit (% of GDP) of Israel in 2008?
Your answer should be very brief. -31.5. What is the difference between the Domestic credit (% of GDP) of Bulgaria in 2005 and the Domestic credit (% of GDP) of Oman in 2008?
Keep it short and to the point. 3.86. What is the difference between the Domestic credit (% of GDP) in Bulgaria in 2005 and the Domestic credit (% of GDP) in St. Kitts and Nevis in 2008?
Provide a succinct answer. -19.34. What is the difference between the Domestic credit (% of GDP) of Israel in 2005 and the Domestic credit (% of GDP) of Oman in 2008?
Ensure brevity in your answer.  41.93. What is the difference between the Domestic credit (% of GDP) in Israel in 2005 and the Domestic credit (% of GDP) in St. Kitts and Nevis in 2008?
Keep it short and to the point. 18.73. What is the difference between the Domestic credit (% of GDP) of Oman in 2005 and the Domestic credit (% of GDP) of St. Kitts and Nevis in 2008?
Provide a short and direct response. -27.66. What is the difference between the Domestic credit (% of GDP) of Bulgaria in 2005 and the Domestic credit (% of GDP) of Israel in 2009?
Your response must be concise. -27.78. What is the difference between the Domestic credit (% of GDP) of Bulgaria in 2005 and the Domestic credit (% of GDP) of Oman in 2009?
Offer a very short reply. -7.7. What is the difference between the Domestic credit (% of GDP) in Bulgaria in 2005 and the Domestic credit (% of GDP) in St. Kitts and Nevis in 2009?
Give a very brief answer. -25.3. What is the difference between the Domestic credit (% of GDP) in Israel in 2005 and the Domestic credit (% of GDP) in Oman in 2009?
Provide a succinct answer. 30.36. What is the difference between the Domestic credit (% of GDP) of Israel in 2005 and the Domestic credit (% of GDP) of St. Kitts and Nevis in 2009?
Your answer should be very brief. 12.77. What is the difference between the Domestic credit (% of GDP) of Oman in 2005 and the Domestic credit (% of GDP) of St. Kitts and Nevis in 2009?
Ensure brevity in your answer.  -33.62. What is the difference between the Domestic credit (% of GDP) of Bulgaria in 2005 and the Domestic credit (% of GDP) of Israel in 2010?
Offer a very short reply. -29.51. What is the difference between the Domestic credit (% of GDP) in Bulgaria in 2005 and the Domestic credit (% of GDP) in Oman in 2010?
Offer a very short reply. -3.36. What is the difference between the Domestic credit (% of GDP) of Bulgaria in 2005 and the Domestic credit (% of GDP) of St. Kitts and Nevis in 2010?
Keep it short and to the point. -28.75. What is the difference between the Domestic credit (% of GDP) of Israel in 2005 and the Domestic credit (% of GDP) of Oman in 2010?
Ensure brevity in your answer.  34.7. What is the difference between the Domestic credit (% of GDP) in Israel in 2005 and the Domestic credit (% of GDP) in St. Kitts and Nevis in 2010?
Offer a very short reply. 9.32. What is the difference between the Domestic credit (% of GDP) of Oman in 2005 and the Domestic credit (% of GDP) of St. Kitts and Nevis in 2010?
Make the answer very short. -37.07. What is the difference between the Domestic credit (% of GDP) of Bulgaria in 2006 and the Domestic credit (% of GDP) of Israel in 2007?
Provide a short and direct response. -25.23. What is the difference between the Domestic credit (% of GDP) of Bulgaria in 2006 and the Domestic credit (% of GDP) of Oman in 2007?
Give a very brief answer. 6.88. What is the difference between the Domestic credit (% of GDP) in Bulgaria in 2006 and the Domestic credit (% of GDP) in St. Kitts and Nevis in 2007?
Make the answer very short. -12.74. What is the difference between the Domestic credit (% of GDP) of Israel in 2006 and the Domestic credit (% of GDP) of Oman in 2007?
Offer a very short reply. 39.15. What is the difference between the Domestic credit (% of GDP) in Israel in 2006 and the Domestic credit (% of GDP) in St. Kitts and Nevis in 2007?
Ensure brevity in your answer.  19.52. What is the difference between the Domestic credit (% of GDP) of Oman in 2006 and the Domestic credit (% of GDP) of St. Kitts and Nevis in 2007?
Ensure brevity in your answer.  -24.42. What is the difference between the Domestic credit (% of GDP) of Bulgaria in 2006 and the Domestic credit (% of GDP) of Israel in 2008?
Provide a short and direct response. -28.06. What is the difference between the Domestic credit (% of GDP) in Bulgaria in 2006 and the Domestic credit (% of GDP) in Oman in 2008?
Ensure brevity in your answer.  7.3. What is the difference between the Domestic credit (% of GDP) of Bulgaria in 2006 and the Domestic credit (% of GDP) of St. Kitts and Nevis in 2008?
Provide a succinct answer. -15.9. What is the difference between the Domestic credit (% of GDP) in Israel in 2006 and the Domestic credit (% of GDP) in Oman in 2008?
Your answer should be very brief. 39.57. What is the difference between the Domestic credit (% of GDP) of Israel in 2006 and the Domestic credit (% of GDP) of St. Kitts and Nevis in 2008?
Offer a very short reply. 16.37. What is the difference between the Domestic credit (% of GDP) of Oman in 2006 and the Domestic credit (% of GDP) of St. Kitts and Nevis in 2008?
Ensure brevity in your answer.  -27.58. What is the difference between the Domestic credit (% of GDP) in Bulgaria in 2006 and the Domestic credit (% of GDP) in Israel in 2009?
Your response must be concise. -24.35. What is the difference between the Domestic credit (% of GDP) in Bulgaria in 2006 and the Domestic credit (% of GDP) in Oman in 2009?
Make the answer very short. -4.27. What is the difference between the Domestic credit (% of GDP) in Bulgaria in 2006 and the Domestic credit (% of GDP) in St. Kitts and Nevis in 2009?
Your answer should be very brief. -21.86. What is the difference between the Domestic credit (% of GDP) in Israel in 2006 and the Domestic credit (% of GDP) in Oman in 2009?
Make the answer very short. 28. What is the difference between the Domestic credit (% of GDP) of Israel in 2006 and the Domestic credit (% of GDP) of St. Kitts and Nevis in 2009?
Your response must be concise. 10.4. What is the difference between the Domestic credit (% of GDP) in Oman in 2006 and the Domestic credit (% of GDP) in St. Kitts and Nevis in 2009?
Your response must be concise. -33.54. What is the difference between the Domestic credit (% of GDP) in Bulgaria in 2006 and the Domestic credit (% of GDP) in Israel in 2010?
Provide a short and direct response. -26.07. What is the difference between the Domestic credit (% of GDP) of Bulgaria in 2006 and the Domestic credit (% of GDP) of Oman in 2010?
Make the answer very short. 0.08. What is the difference between the Domestic credit (% of GDP) in Bulgaria in 2006 and the Domestic credit (% of GDP) in St. Kitts and Nevis in 2010?
Your response must be concise. -25.31. What is the difference between the Domestic credit (% of GDP) of Israel in 2006 and the Domestic credit (% of GDP) of Oman in 2010?
Ensure brevity in your answer.  32.34. What is the difference between the Domestic credit (% of GDP) in Israel in 2006 and the Domestic credit (% of GDP) in St. Kitts and Nevis in 2010?
Your answer should be compact. 6.96. What is the difference between the Domestic credit (% of GDP) in Oman in 2006 and the Domestic credit (% of GDP) in St. Kitts and Nevis in 2010?
Provide a short and direct response. -36.99. What is the difference between the Domestic credit (% of GDP) in Bulgaria in 2007 and the Domestic credit (% of GDP) in Israel in 2008?
Keep it short and to the point. -12.56. What is the difference between the Domestic credit (% of GDP) in Bulgaria in 2007 and the Domestic credit (% of GDP) in Oman in 2008?
Make the answer very short. 22.8. What is the difference between the Domestic credit (% of GDP) in Bulgaria in 2007 and the Domestic credit (% of GDP) in St. Kitts and Nevis in 2008?
Provide a succinct answer. -0.4. What is the difference between the Domestic credit (% of GDP) in Israel in 2007 and the Domestic credit (% of GDP) in Oman in 2008?
Make the answer very short. 32.53. What is the difference between the Domestic credit (% of GDP) of Israel in 2007 and the Domestic credit (% of GDP) of St. Kitts and Nevis in 2008?
Keep it short and to the point. 9.33. What is the difference between the Domestic credit (% of GDP) of Oman in 2007 and the Domestic credit (% of GDP) of St. Kitts and Nevis in 2008?
Your answer should be compact. -22.78. What is the difference between the Domestic credit (% of GDP) of Bulgaria in 2007 and the Domestic credit (% of GDP) of Israel in 2009?
Ensure brevity in your answer.  -8.85. What is the difference between the Domestic credit (% of GDP) of Bulgaria in 2007 and the Domestic credit (% of GDP) of Oman in 2009?
Provide a short and direct response. 11.23. What is the difference between the Domestic credit (% of GDP) in Bulgaria in 2007 and the Domestic credit (% of GDP) in St. Kitts and Nevis in 2009?
Offer a terse response. -6.36. What is the difference between the Domestic credit (% of GDP) of Israel in 2007 and the Domestic credit (% of GDP) of Oman in 2009?
Offer a very short reply. 20.96. What is the difference between the Domestic credit (% of GDP) in Israel in 2007 and the Domestic credit (% of GDP) in St. Kitts and Nevis in 2009?
Offer a terse response. 3.37. What is the difference between the Domestic credit (% of GDP) in Oman in 2007 and the Domestic credit (% of GDP) in St. Kitts and Nevis in 2009?
Your answer should be compact. -28.74. What is the difference between the Domestic credit (% of GDP) of Bulgaria in 2007 and the Domestic credit (% of GDP) of Israel in 2010?
Offer a terse response. -10.57. What is the difference between the Domestic credit (% of GDP) in Bulgaria in 2007 and the Domestic credit (% of GDP) in Oman in 2010?
Your response must be concise. 15.58. What is the difference between the Domestic credit (% of GDP) in Bulgaria in 2007 and the Domestic credit (% of GDP) in St. Kitts and Nevis in 2010?
Your answer should be compact. -9.81. What is the difference between the Domestic credit (% of GDP) of Israel in 2007 and the Domestic credit (% of GDP) of Oman in 2010?
Give a very brief answer. 25.3. What is the difference between the Domestic credit (% of GDP) in Israel in 2007 and the Domestic credit (% of GDP) in St. Kitts and Nevis in 2010?
Make the answer very short. -0.08. What is the difference between the Domestic credit (% of GDP) of Oman in 2007 and the Domestic credit (% of GDP) of St. Kitts and Nevis in 2010?
Offer a terse response. -32.19. What is the difference between the Domestic credit (% of GDP) in Bulgaria in 2008 and the Domestic credit (% of GDP) in Israel in 2009?
Offer a very short reply. -0.16. What is the difference between the Domestic credit (% of GDP) in Bulgaria in 2008 and the Domestic credit (% of GDP) in Oman in 2009?
Make the answer very short. 19.92. What is the difference between the Domestic credit (% of GDP) of Bulgaria in 2008 and the Domestic credit (% of GDP) of St. Kitts and Nevis in 2009?
Give a very brief answer. 2.32. What is the difference between the Domestic credit (% of GDP) in Israel in 2008 and the Domestic credit (% of GDP) in Oman in 2009?
Ensure brevity in your answer.  23.79. What is the difference between the Domestic credit (% of GDP) of Israel in 2008 and the Domestic credit (% of GDP) of St. Kitts and Nevis in 2009?
Ensure brevity in your answer.  6.2. What is the difference between the Domestic credit (% of GDP) in Oman in 2008 and the Domestic credit (% of GDP) in St. Kitts and Nevis in 2009?
Ensure brevity in your answer.  -29.16. What is the difference between the Domestic credit (% of GDP) in Bulgaria in 2008 and the Domestic credit (% of GDP) in Israel in 2010?
Provide a short and direct response. -1.88. What is the difference between the Domestic credit (% of GDP) in Bulgaria in 2008 and the Domestic credit (% of GDP) in Oman in 2010?
Make the answer very short. 24.26. What is the difference between the Domestic credit (% of GDP) of Bulgaria in 2008 and the Domestic credit (% of GDP) of St. Kitts and Nevis in 2010?
Ensure brevity in your answer.  -1.12. What is the difference between the Domestic credit (% of GDP) of Israel in 2008 and the Domestic credit (% of GDP) of Oman in 2010?
Make the answer very short. 28.14. What is the difference between the Domestic credit (% of GDP) of Israel in 2008 and the Domestic credit (% of GDP) of St. Kitts and Nevis in 2010?
Your answer should be compact. 2.75. What is the difference between the Domestic credit (% of GDP) of Oman in 2008 and the Domestic credit (% of GDP) of St. Kitts and Nevis in 2010?
Keep it short and to the point. -32.61. What is the difference between the Domestic credit (% of GDP) in Bulgaria in 2009 and the Domestic credit (% of GDP) in Israel in 2010?
Your response must be concise. 0.7. What is the difference between the Domestic credit (% of GDP) of Bulgaria in 2009 and the Domestic credit (% of GDP) of Oman in 2010?
Your response must be concise. 26.85. What is the difference between the Domestic credit (% of GDP) of Bulgaria in 2009 and the Domestic credit (% of GDP) of St. Kitts and Nevis in 2010?
Keep it short and to the point. 1.46. What is the difference between the Domestic credit (% of GDP) of Israel in 2009 and the Domestic credit (% of GDP) of Oman in 2010?
Your response must be concise. 24.42. What is the difference between the Domestic credit (% of GDP) in Israel in 2009 and the Domestic credit (% of GDP) in St. Kitts and Nevis in 2010?
Your answer should be very brief. -0.96. What is the difference between the Domestic credit (% of GDP) in Oman in 2009 and the Domestic credit (% of GDP) in St. Kitts and Nevis in 2010?
Offer a terse response. -21.04. What is the average Domestic credit (% of GDP) in Bulgaria per year?
Make the answer very short. 50.38. What is the average Domestic credit (% of GDP) of Israel per year?
Provide a short and direct response. 72.01. What is the average Domestic credit (% of GDP) in Oman per year?
Your answer should be compact. 36.5. What is the average Domestic credit (% of GDP) in St. Kitts and Nevis per year?
Your response must be concise. 57.87. In the year 2003, what is the difference between the Domestic credit (% of GDP) of Bulgaria and Domestic credit (% of GDP) of Israel?
Your answer should be very brief. -50.78. In the year 2003, what is the difference between the Domestic credit (% of GDP) of Bulgaria and Domestic credit (% of GDP) of Oman?
Make the answer very short. -11.01. In the year 2003, what is the difference between the Domestic credit (% of GDP) of Bulgaria and Domestic credit (% of GDP) of St. Kitts and Nevis?
Offer a terse response. -29.21. In the year 2003, what is the difference between the Domestic credit (% of GDP) in Israel and Domestic credit (% of GDP) in Oman?
Make the answer very short. 39.77. In the year 2003, what is the difference between the Domestic credit (% of GDP) in Israel and Domestic credit (% of GDP) in St. Kitts and Nevis?
Offer a terse response. 21.57. In the year 2003, what is the difference between the Domestic credit (% of GDP) in Oman and Domestic credit (% of GDP) in St. Kitts and Nevis?
Provide a short and direct response. -18.2. In the year 2004, what is the difference between the Domestic credit (% of GDP) of Bulgaria and Domestic credit (% of GDP) of Israel?
Offer a very short reply. -41.42. In the year 2004, what is the difference between the Domestic credit (% of GDP) of Bulgaria and Domestic credit (% of GDP) of Oman?
Provide a succinct answer. -1.17. In the year 2004, what is the difference between the Domestic credit (% of GDP) in Bulgaria and Domestic credit (% of GDP) in St. Kitts and Nevis?
Provide a short and direct response. -22.27. In the year 2004, what is the difference between the Domestic credit (% of GDP) in Israel and Domestic credit (% of GDP) in Oman?
Your response must be concise. 40.25. In the year 2004, what is the difference between the Domestic credit (% of GDP) of Israel and Domestic credit (% of GDP) of St. Kitts and Nevis?
Provide a short and direct response. 19.16. In the year 2004, what is the difference between the Domestic credit (% of GDP) of Oman and Domestic credit (% of GDP) of St. Kitts and Nevis?
Make the answer very short. -21.09. In the year 2005, what is the difference between the Domestic credit (% of GDP) in Bulgaria and Domestic credit (% of GDP) in Israel?
Your response must be concise. -38.06. In the year 2005, what is the difference between the Domestic credit (% of GDP) in Bulgaria and Domestic credit (% of GDP) in Oman?
Offer a terse response. 8.32. In the year 2005, what is the difference between the Domestic credit (% of GDP) of Bulgaria and Domestic credit (% of GDP) of St. Kitts and Nevis?
Provide a succinct answer. -15.89. In the year 2005, what is the difference between the Domestic credit (% of GDP) in Israel and Domestic credit (% of GDP) in Oman?
Keep it short and to the point. 46.39. In the year 2005, what is the difference between the Domestic credit (% of GDP) of Israel and Domestic credit (% of GDP) of St. Kitts and Nevis?
Give a very brief answer. 22.17. In the year 2005, what is the difference between the Domestic credit (% of GDP) in Oman and Domestic credit (% of GDP) in St. Kitts and Nevis?
Keep it short and to the point. -24.21. In the year 2006, what is the difference between the Domestic credit (% of GDP) of Bulgaria and Domestic credit (% of GDP) of Israel?
Provide a succinct answer. -32.27. In the year 2006, what is the difference between the Domestic credit (% of GDP) in Bulgaria and Domestic credit (% of GDP) in Oman?
Make the answer very short. 11.68. In the year 2006, what is the difference between the Domestic credit (% of GDP) of Bulgaria and Domestic credit (% of GDP) of St. Kitts and Nevis?
Give a very brief answer. -9.97. In the year 2006, what is the difference between the Domestic credit (% of GDP) in Israel and Domestic credit (% of GDP) in Oman?
Ensure brevity in your answer.  43.94. In the year 2006, what is the difference between the Domestic credit (% of GDP) of Israel and Domestic credit (% of GDP) of St. Kitts and Nevis?
Your response must be concise. 22.3. In the year 2006, what is the difference between the Domestic credit (% of GDP) of Oman and Domestic credit (% of GDP) of St. Kitts and Nevis?
Offer a very short reply. -21.65. In the year 2007, what is the difference between the Domestic credit (% of GDP) in Bulgaria and Domestic credit (% of GDP) in Israel?
Ensure brevity in your answer.  -9.73. In the year 2007, what is the difference between the Domestic credit (% of GDP) in Bulgaria and Domestic credit (% of GDP) in Oman?
Your response must be concise. 22.38. In the year 2007, what is the difference between the Domestic credit (% of GDP) in Bulgaria and Domestic credit (% of GDP) in St. Kitts and Nevis?
Give a very brief answer. 2.76. In the year 2007, what is the difference between the Domestic credit (% of GDP) of Israel and Domestic credit (% of GDP) of Oman?
Offer a terse response. 32.11. In the year 2007, what is the difference between the Domestic credit (% of GDP) in Israel and Domestic credit (% of GDP) in St. Kitts and Nevis?
Your answer should be very brief. 12.49. In the year 2007, what is the difference between the Domestic credit (% of GDP) in Oman and Domestic credit (% of GDP) in St. Kitts and Nevis?
Give a very brief answer. -19.62. In the year 2008, what is the difference between the Domestic credit (% of GDP) of Bulgaria and Domestic credit (% of GDP) of Israel?
Your answer should be very brief. -3.87. In the year 2008, what is the difference between the Domestic credit (% of GDP) in Bulgaria and Domestic credit (% of GDP) in Oman?
Provide a short and direct response. 31.49. In the year 2008, what is the difference between the Domestic credit (% of GDP) of Bulgaria and Domestic credit (% of GDP) of St. Kitts and Nevis?
Ensure brevity in your answer.  8.29. In the year 2008, what is the difference between the Domestic credit (% of GDP) in Israel and Domestic credit (% of GDP) in Oman?
Your answer should be compact. 35.36. In the year 2008, what is the difference between the Domestic credit (% of GDP) of Israel and Domestic credit (% of GDP) of St. Kitts and Nevis?
Offer a very short reply. 12.16. In the year 2008, what is the difference between the Domestic credit (% of GDP) of Oman and Domestic credit (% of GDP) of St. Kitts and Nevis?
Keep it short and to the point. -23.2. In the year 2009, what is the difference between the Domestic credit (% of GDP) of Bulgaria and Domestic credit (% of GDP) of Israel?
Your answer should be very brief. 2.42. In the year 2009, what is the difference between the Domestic credit (% of GDP) of Bulgaria and Domestic credit (% of GDP) of Oman?
Offer a terse response. 22.5. In the year 2009, what is the difference between the Domestic credit (% of GDP) of Bulgaria and Domestic credit (% of GDP) of St. Kitts and Nevis?
Your response must be concise. 4.91. In the year 2009, what is the difference between the Domestic credit (% of GDP) of Israel and Domestic credit (% of GDP) of Oman?
Provide a short and direct response. 20.08. In the year 2009, what is the difference between the Domestic credit (% of GDP) in Israel and Domestic credit (% of GDP) in St. Kitts and Nevis?
Provide a short and direct response. 2.49. In the year 2009, what is the difference between the Domestic credit (% of GDP) of Oman and Domestic credit (% of GDP) of St. Kitts and Nevis?
Your answer should be very brief. -17.6. In the year 2010, what is the difference between the Domestic credit (% of GDP) in Bulgaria and Domestic credit (% of GDP) in Israel?
Your answer should be compact. 0.65. In the year 2010, what is the difference between the Domestic credit (% of GDP) of Bulgaria and Domestic credit (% of GDP) of Oman?
Provide a succinct answer. 26.8. In the year 2010, what is the difference between the Domestic credit (% of GDP) in Bulgaria and Domestic credit (% of GDP) in St. Kitts and Nevis?
Your response must be concise. 1.41. In the year 2010, what is the difference between the Domestic credit (% of GDP) of Israel and Domestic credit (% of GDP) of Oman?
Provide a succinct answer. 26.14. In the year 2010, what is the difference between the Domestic credit (% of GDP) in Israel and Domestic credit (% of GDP) in St. Kitts and Nevis?
Provide a short and direct response. 0.76. In the year 2010, what is the difference between the Domestic credit (% of GDP) of Oman and Domestic credit (% of GDP) of St. Kitts and Nevis?
Provide a succinct answer. -25.38. What is the ratio of the Domestic credit (% of GDP) of Bulgaria in 2003 to that in 2004?
Give a very brief answer. 0.78. What is the ratio of the Domestic credit (% of GDP) in Israel in 2003 to that in 2004?
Offer a terse response. 1.03. What is the ratio of the Domestic credit (% of GDP) in Oman in 2003 to that in 2004?
Make the answer very short. 1.07. What is the ratio of the Domestic credit (% of GDP) in St. Kitts and Nevis in 2003 to that in 2004?
Ensure brevity in your answer.  0.99. What is the ratio of the Domestic credit (% of GDP) of Bulgaria in 2003 to that in 2005?
Your answer should be very brief. 0.66. What is the ratio of the Domestic credit (% of GDP) in Israel in 2003 to that in 2005?
Keep it short and to the point. 0.99. What is the ratio of the Domestic credit (% of GDP) in Oman in 2003 to that in 2005?
Your response must be concise. 1.2. What is the ratio of the Domestic credit (% of GDP) in St. Kitts and Nevis in 2003 to that in 2005?
Ensure brevity in your answer.  1. What is the ratio of the Domestic credit (% of GDP) of Bulgaria in 2003 to that in 2006?
Your answer should be compact. 0.61. What is the ratio of the Domestic credit (% of GDP) of Israel in 2003 to that in 2006?
Give a very brief answer. 1.03. What is the ratio of the Domestic credit (% of GDP) in Oman in 2003 to that in 2006?
Keep it short and to the point. 1.2. What is the ratio of the Domestic credit (% of GDP) in St. Kitts and Nevis in 2003 to that in 2006?
Your response must be concise. 1.05. What is the ratio of the Domestic credit (% of GDP) in Bulgaria in 2003 to that in 2007?
Offer a very short reply. 0.45. What is the ratio of the Domestic credit (% of GDP) in Israel in 2003 to that in 2007?
Keep it short and to the point. 1.13. What is the ratio of the Domestic credit (% of GDP) in Oman in 2003 to that in 2007?
Ensure brevity in your answer.  1.04. What is the ratio of the Domestic credit (% of GDP) of St. Kitts and Nevis in 2003 to that in 2007?
Your answer should be very brief. 1. What is the ratio of the Domestic credit (% of GDP) in Bulgaria in 2003 to that in 2008?
Offer a very short reply. 0.39. What is the ratio of the Domestic credit (% of GDP) in Israel in 2003 to that in 2008?
Keep it short and to the point. 1.09. What is the ratio of the Domestic credit (% of GDP) of Oman in 2003 to that in 2008?
Make the answer very short. 1.05. What is the ratio of the Domestic credit (% of GDP) of St. Kitts and Nevis in 2003 to that in 2008?
Offer a very short reply. 0.94. What is the ratio of the Domestic credit (% of GDP) in Bulgaria in 2003 to that in 2009?
Your response must be concise. 0.37. What is the ratio of the Domestic credit (% of GDP) of Israel in 2003 to that in 2009?
Keep it short and to the point. 1.15. What is the ratio of the Domestic credit (% of GDP) of Oman in 2003 to that in 2009?
Offer a very short reply. 0.79. What is the ratio of the Domestic credit (% of GDP) of St. Kitts and Nevis in 2003 to that in 2009?
Ensure brevity in your answer.  0.86. What is the ratio of the Domestic credit (% of GDP) of Bulgaria in 2003 to that in 2010?
Make the answer very short. 0.37. What is the ratio of the Domestic credit (% of GDP) of Israel in 2003 to that in 2010?
Your answer should be very brief. 1.12. What is the ratio of the Domestic credit (% of GDP) of Oman in 2003 to that in 2010?
Offer a terse response. 0.87. What is the ratio of the Domestic credit (% of GDP) in St. Kitts and Nevis in 2003 to that in 2010?
Offer a very short reply. 0.81. What is the ratio of the Domestic credit (% of GDP) of Bulgaria in 2004 to that in 2005?
Offer a very short reply. 0.85. What is the ratio of the Domestic credit (% of GDP) in Israel in 2004 to that in 2005?
Give a very brief answer. 0.97. What is the ratio of the Domestic credit (% of GDP) in Oman in 2004 to that in 2005?
Give a very brief answer. 1.12. What is the ratio of the Domestic credit (% of GDP) in St. Kitts and Nevis in 2004 to that in 2005?
Offer a terse response. 1.01. What is the ratio of the Domestic credit (% of GDP) in Bulgaria in 2004 to that in 2006?
Your answer should be very brief. 0.78. What is the ratio of the Domestic credit (% of GDP) of Israel in 2004 to that in 2006?
Keep it short and to the point. 1. What is the ratio of the Domestic credit (% of GDP) in Oman in 2004 to that in 2006?
Offer a terse response. 1.11. What is the ratio of the Domestic credit (% of GDP) of St. Kitts and Nevis in 2004 to that in 2006?
Your answer should be compact. 1.06. What is the ratio of the Domestic credit (% of GDP) of Bulgaria in 2004 to that in 2007?
Your answer should be very brief. 0.57. What is the ratio of the Domestic credit (% of GDP) in Israel in 2004 to that in 2007?
Give a very brief answer. 1.1. What is the ratio of the Domestic credit (% of GDP) of Oman in 2004 to that in 2007?
Offer a very short reply. 0.96. What is the ratio of the Domestic credit (% of GDP) of St. Kitts and Nevis in 2004 to that in 2007?
Make the answer very short. 1. What is the ratio of the Domestic credit (% of GDP) in Bulgaria in 2004 to that in 2008?
Offer a terse response. 0.5. What is the ratio of the Domestic credit (% of GDP) of Israel in 2004 to that in 2008?
Offer a very short reply. 1.06. What is the ratio of the Domestic credit (% of GDP) of Oman in 2004 to that in 2008?
Provide a succinct answer. 0.97. What is the ratio of the Domestic credit (% of GDP) of St. Kitts and Nevis in 2004 to that in 2008?
Keep it short and to the point. 0.95. What is the ratio of the Domestic credit (% of GDP) of Bulgaria in 2004 to that in 2009?
Provide a short and direct response. 0.48. What is the ratio of the Domestic credit (% of GDP) in Israel in 2004 to that in 2009?
Provide a succinct answer. 1.12. What is the ratio of the Domestic credit (% of GDP) in Oman in 2004 to that in 2009?
Provide a succinct answer. 0.73. What is the ratio of the Domestic credit (% of GDP) in St. Kitts and Nevis in 2004 to that in 2009?
Make the answer very short. 0.86. What is the ratio of the Domestic credit (% of GDP) in Bulgaria in 2004 to that in 2010?
Keep it short and to the point. 0.48. What is the ratio of the Domestic credit (% of GDP) of Israel in 2004 to that in 2010?
Ensure brevity in your answer.  1.09. What is the ratio of the Domestic credit (% of GDP) of Oman in 2004 to that in 2010?
Make the answer very short. 0.81. What is the ratio of the Domestic credit (% of GDP) in St. Kitts and Nevis in 2004 to that in 2010?
Offer a very short reply. 0.82. What is the ratio of the Domestic credit (% of GDP) in Bulgaria in 2005 to that in 2006?
Offer a very short reply. 0.92. What is the ratio of the Domestic credit (% of GDP) of Israel in 2005 to that in 2006?
Keep it short and to the point. 1.03. What is the ratio of the Domestic credit (% of GDP) of Oman in 2005 to that in 2006?
Ensure brevity in your answer.  1. What is the ratio of the Domestic credit (% of GDP) of St. Kitts and Nevis in 2005 to that in 2006?
Your answer should be very brief. 1.05. What is the ratio of the Domestic credit (% of GDP) of Bulgaria in 2005 to that in 2007?
Your response must be concise. 0.67. What is the ratio of the Domestic credit (% of GDP) in Israel in 2005 to that in 2007?
Give a very brief answer. 1.14. What is the ratio of the Domestic credit (% of GDP) in Oman in 2005 to that in 2007?
Provide a succinct answer. 0.86. What is the ratio of the Domestic credit (% of GDP) of St. Kitts and Nevis in 2005 to that in 2007?
Your answer should be compact. 0.99. What is the ratio of the Domestic credit (% of GDP) in Bulgaria in 2005 to that in 2008?
Offer a terse response. 0.59. What is the ratio of the Domestic credit (% of GDP) in Israel in 2005 to that in 2008?
Offer a very short reply. 1.09. What is the ratio of the Domestic credit (% of GDP) of Oman in 2005 to that in 2008?
Your response must be concise. 0.87. What is the ratio of the Domestic credit (% of GDP) in St. Kitts and Nevis in 2005 to that in 2008?
Offer a very short reply. 0.94. What is the ratio of the Domestic credit (% of GDP) in Bulgaria in 2005 to that in 2009?
Provide a short and direct response. 0.56. What is the ratio of the Domestic credit (% of GDP) in Israel in 2005 to that in 2009?
Make the answer very short. 1.15. What is the ratio of the Domestic credit (% of GDP) in Oman in 2005 to that in 2009?
Ensure brevity in your answer.  0.66. What is the ratio of the Domestic credit (% of GDP) of St. Kitts and Nevis in 2005 to that in 2009?
Your answer should be compact. 0.85. What is the ratio of the Domestic credit (% of GDP) in Bulgaria in 2005 to that in 2010?
Ensure brevity in your answer.  0.56. What is the ratio of the Domestic credit (% of GDP) in Israel in 2005 to that in 2010?
Make the answer very short. 1.12. What is the ratio of the Domestic credit (% of GDP) in Oman in 2005 to that in 2010?
Make the answer very short. 0.72. What is the ratio of the Domestic credit (% of GDP) in St. Kitts and Nevis in 2005 to that in 2010?
Provide a succinct answer. 0.81. What is the ratio of the Domestic credit (% of GDP) in Bulgaria in 2006 to that in 2007?
Keep it short and to the point. 0.73. What is the ratio of the Domestic credit (% of GDP) in Israel in 2006 to that in 2007?
Provide a short and direct response. 1.1. What is the ratio of the Domestic credit (% of GDP) of Oman in 2006 to that in 2007?
Keep it short and to the point. 0.86. What is the ratio of the Domestic credit (% of GDP) of St. Kitts and Nevis in 2006 to that in 2007?
Make the answer very short. 0.95. What is the ratio of the Domestic credit (% of GDP) in Bulgaria in 2006 to that in 2008?
Your response must be concise. 0.64. What is the ratio of the Domestic credit (% of GDP) in Israel in 2006 to that in 2008?
Provide a short and direct response. 1.06. What is the ratio of the Domestic credit (% of GDP) in Oman in 2006 to that in 2008?
Your answer should be compact. 0.88. What is the ratio of the Domestic credit (% of GDP) of St. Kitts and Nevis in 2006 to that in 2008?
Offer a very short reply. 0.9. What is the ratio of the Domestic credit (% of GDP) in Bulgaria in 2006 to that in 2009?
Your answer should be compact. 0.61. What is the ratio of the Domestic credit (% of GDP) of Israel in 2006 to that in 2009?
Provide a short and direct response. 1.12. What is the ratio of the Domestic credit (% of GDP) of Oman in 2006 to that in 2009?
Keep it short and to the point. 0.66. What is the ratio of the Domestic credit (% of GDP) in St. Kitts and Nevis in 2006 to that in 2009?
Your answer should be very brief. 0.81. What is the ratio of the Domestic credit (% of GDP) in Bulgaria in 2006 to that in 2010?
Make the answer very short. 0.61. What is the ratio of the Domestic credit (% of GDP) in Israel in 2006 to that in 2010?
Your answer should be compact. 1.09. What is the ratio of the Domestic credit (% of GDP) in Oman in 2006 to that in 2010?
Keep it short and to the point. 0.73. What is the ratio of the Domestic credit (% of GDP) in St. Kitts and Nevis in 2006 to that in 2010?
Your answer should be very brief. 0.77. What is the ratio of the Domestic credit (% of GDP) of Bulgaria in 2007 to that in 2008?
Keep it short and to the point. 0.87. What is the ratio of the Domestic credit (% of GDP) in Israel in 2007 to that in 2008?
Provide a short and direct response. 0.96. What is the ratio of the Domestic credit (% of GDP) in Oman in 2007 to that in 2008?
Ensure brevity in your answer.  1.01. What is the ratio of the Domestic credit (% of GDP) of St. Kitts and Nevis in 2007 to that in 2008?
Your response must be concise. 0.95. What is the ratio of the Domestic credit (% of GDP) in Bulgaria in 2007 to that in 2009?
Offer a very short reply. 0.84. What is the ratio of the Domestic credit (% of GDP) of Israel in 2007 to that in 2009?
Offer a terse response. 1.01. What is the ratio of the Domestic credit (% of GDP) in Oman in 2007 to that in 2009?
Provide a succinct answer. 0.76. What is the ratio of the Domestic credit (% of GDP) in St. Kitts and Nevis in 2007 to that in 2009?
Provide a short and direct response. 0.86. What is the ratio of the Domestic credit (% of GDP) in Bulgaria in 2007 to that in 2010?
Ensure brevity in your answer.  0.84. What is the ratio of the Domestic credit (% of GDP) in Israel in 2007 to that in 2010?
Your response must be concise. 0.99. What is the ratio of the Domestic credit (% of GDP) of Oman in 2007 to that in 2010?
Provide a short and direct response. 0.84. What is the ratio of the Domestic credit (% of GDP) of St. Kitts and Nevis in 2007 to that in 2010?
Provide a short and direct response. 0.81. What is the ratio of the Domestic credit (% of GDP) of Bulgaria in 2008 to that in 2009?
Provide a short and direct response. 0.96. What is the ratio of the Domestic credit (% of GDP) of Israel in 2008 to that in 2009?
Your answer should be compact. 1.06. What is the ratio of the Domestic credit (% of GDP) in Oman in 2008 to that in 2009?
Offer a very short reply. 0.75. What is the ratio of the Domestic credit (% of GDP) of St. Kitts and Nevis in 2008 to that in 2009?
Keep it short and to the point. 0.91. What is the ratio of the Domestic credit (% of GDP) of Bulgaria in 2008 to that in 2010?
Your answer should be very brief. 0.96. What is the ratio of the Domestic credit (% of GDP) in Israel in 2008 to that in 2010?
Ensure brevity in your answer.  1.03. What is the ratio of the Domestic credit (% of GDP) of Oman in 2008 to that in 2010?
Make the answer very short. 0.83. What is the ratio of the Domestic credit (% of GDP) of St. Kitts and Nevis in 2008 to that in 2010?
Your answer should be very brief. 0.86. What is the ratio of the Domestic credit (% of GDP) in Israel in 2009 to that in 2010?
Provide a succinct answer. 0.97. What is the ratio of the Domestic credit (% of GDP) in Oman in 2009 to that in 2010?
Keep it short and to the point. 1.1. What is the ratio of the Domestic credit (% of GDP) of St. Kitts and Nevis in 2009 to that in 2010?
Offer a terse response. 0.95. What is the difference between the highest and the second highest Domestic credit (% of GDP) in Bulgaria?
Your response must be concise. 0.05. What is the difference between the highest and the second highest Domestic credit (% of GDP) of Israel?
Your response must be concise. 0.48. What is the difference between the highest and the second highest Domestic credit (% of GDP) in Oman?
Your response must be concise. 4.34. What is the difference between the highest and the second highest Domestic credit (% of GDP) of St. Kitts and Nevis?
Ensure brevity in your answer.  3.45. What is the difference between the highest and the lowest Domestic credit (% of GDP) of Bulgaria?
Offer a very short reply. 43.4. What is the difference between the highest and the lowest Domestic credit (% of GDP) of Israel?
Provide a short and direct response. 10.28. What is the difference between the highest and the lowest Domestic credit (% of GDP) in Oman?
Provide a succinct answer. 16.03. What is the difference between the highest and the lowest Domestic credit (% of GDP) in St. Kitts and Nevis?
Offer a terse response. 15.34. 